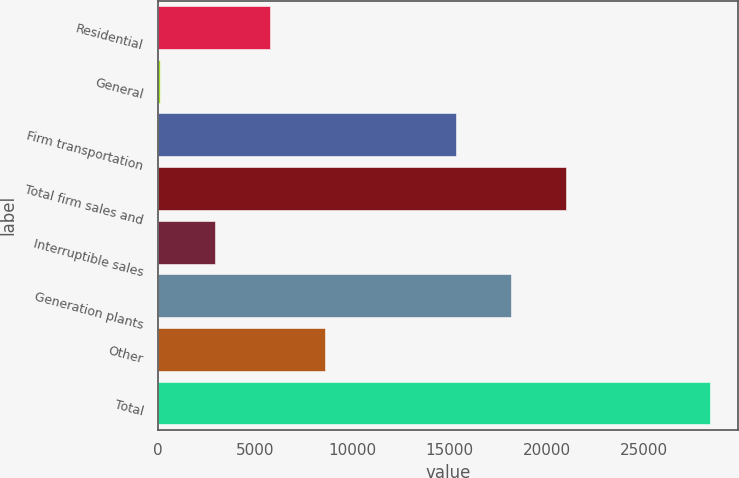<chart> <loc_0><loc_0><loc_500><loc_500><bar_chart><fcel>Residential<fcel>General<fcel>Firm transportation<fcel>Total firm sales and<fcel>Interruptible sales<fcel>Generation plants<fcel>Other<fcel>Total<nl><fcel>5762.8<fcel>107<fcel>15328<fcel>20983.8<fcel>2934.9<fcel>18155.9<fcel>8590.7<fcel>28386<nl></chart> 